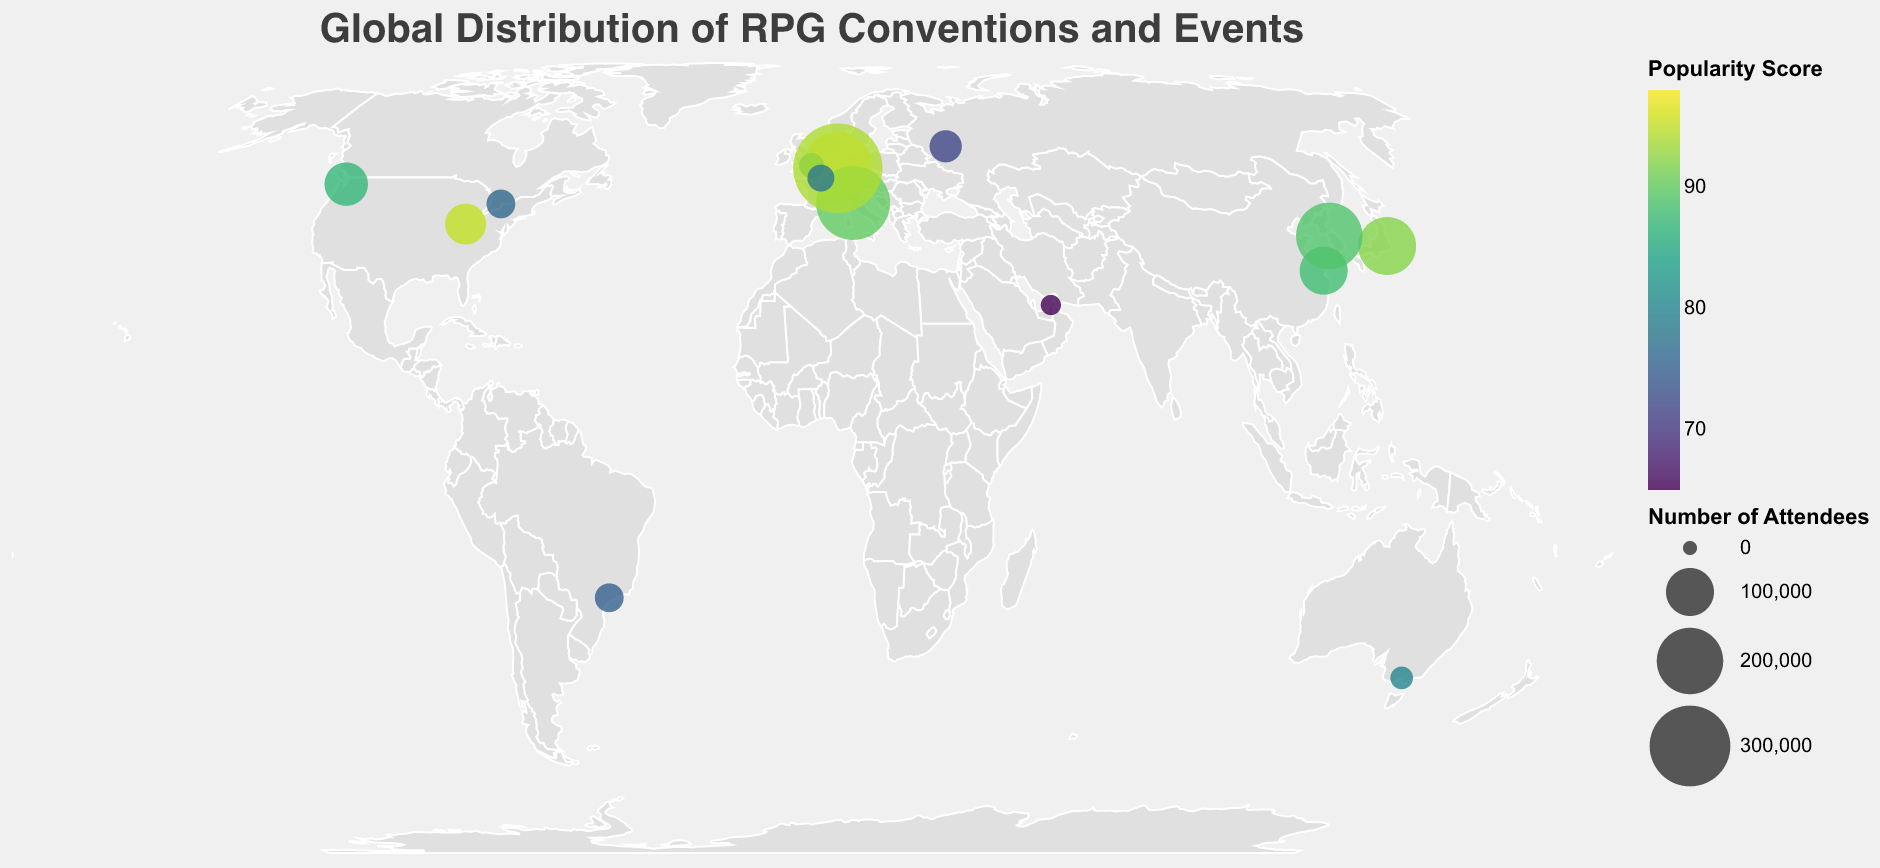what is the title of the figure? The title of the figure is usually displayed at the top and provides a summary of what the figure represents. In this case, the title is displayed as "Global Distribution of RPG Conventions and Events."
Answer: Global Distribution of RPG Conventions and Events Which event has the highest number of attendees? Look at the size of the circles on the map. The largest circle represents the event with the highest number of attendees. By observing the size, you can see that Gamescom in Cologne, Germany, has the largest circle size, indicating the highest number of attendees (370,000).
Answer: Gamescom What is the popularity score of the event in Tokyo, Japan? Hover over the circle representing Tokyo, Japan, or refer to the tooltip information specific to the location. The tooltip will show the popularity score along with other details. The Tokyo Game Market in Tokyo has a popularity score of 92.
Answer: 92 Which event type in Asia has the most attendees? Identify the events located in Asia by looking at the geographic locations of the circles. Then compare their sizes to determine the event with the most attendees. The event in Asia with the highest number of attendees is Shanghai's ChinaJoy with 100,000 attendees.
Answer: G-Star Which country hosts the most events shown in the figure? Count the number of circles (representing events) located in each country. The country with the most circles hosts the most events. The USA hosts the most events shown in the figure, with two events: Gen Con in Indianapolis and PAX West in Seattle.
Answer: USA How does the popularity score of Lucca Comics & Games compare to that of PAX West? Look at the color intensity of the circles representing these two events. Lucca Comics & Games has a popularity score of 90, while PAX West has a popularity score of 87. Therefore, Lucca Comics & Games is slightly more popular.
Answer: Lucca Comics & Games is more popular What is the average popularity score of all the listed events? To calculate the average, sum up the popularity scores of all events and then divide by the number of events. The scores are: 95, 98, 85, 92, 80, 75, 88, 90, 94, 87, 78, 72, 76, 89, 65. Summing these gives 1264, and there are 15 events. The average score = 1264 / 15 = 84.27.
Answer: 84.27 Which city has the event with the smallest number of attendees? Identify the smallest circle on the map. The smallest circle represents the event with the fewest attendees. The Middle East Games Con in Dubai has the smallest number of attendees, which is 10,000.
Answer: Dubai Which two continents have the highest cumulative number of attendees? Calculate the total number of attendees for events in each continent, then compare the sums. Europe: 250,000 (Lucca), 370,000 (Cologne), 210,000 (Essen), 25,000 (Paris), totaling 855,000. Asia: 150,000 (Tokyo), 100,000 (Shanghai), 200,000 (Seoul), 10,000 (Dubai), totaling 460,000. North America: 70,000 (Indianapolis), 80,000 (Seattle), 30,000 (Toronto), totaling 180,000. Adding the cumulative number for each continent, we see that Europe and Asia have the highest cumulative number of attendees.
Answer: Europe and Asia 